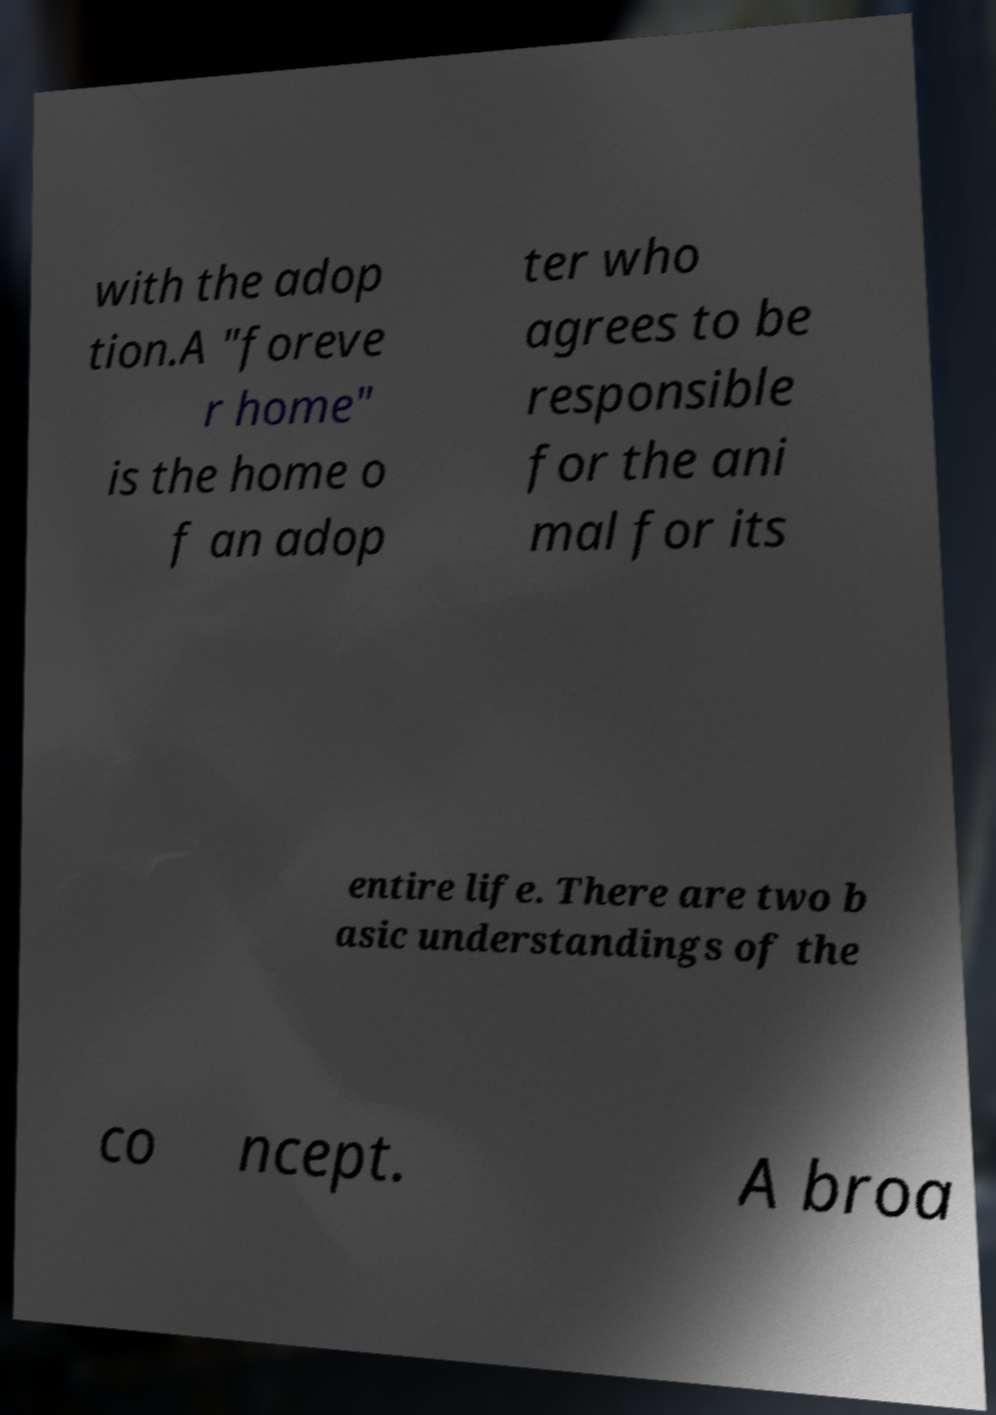There's text embedded in this image that I need extracted. Can you transcribe it verbatim? with the adop tion.A "foreve r home" is the home o f an adop ter who agrees to be responsible for the ani mal for its entire life. There are two b asic understandings of the co ncept. A broa 